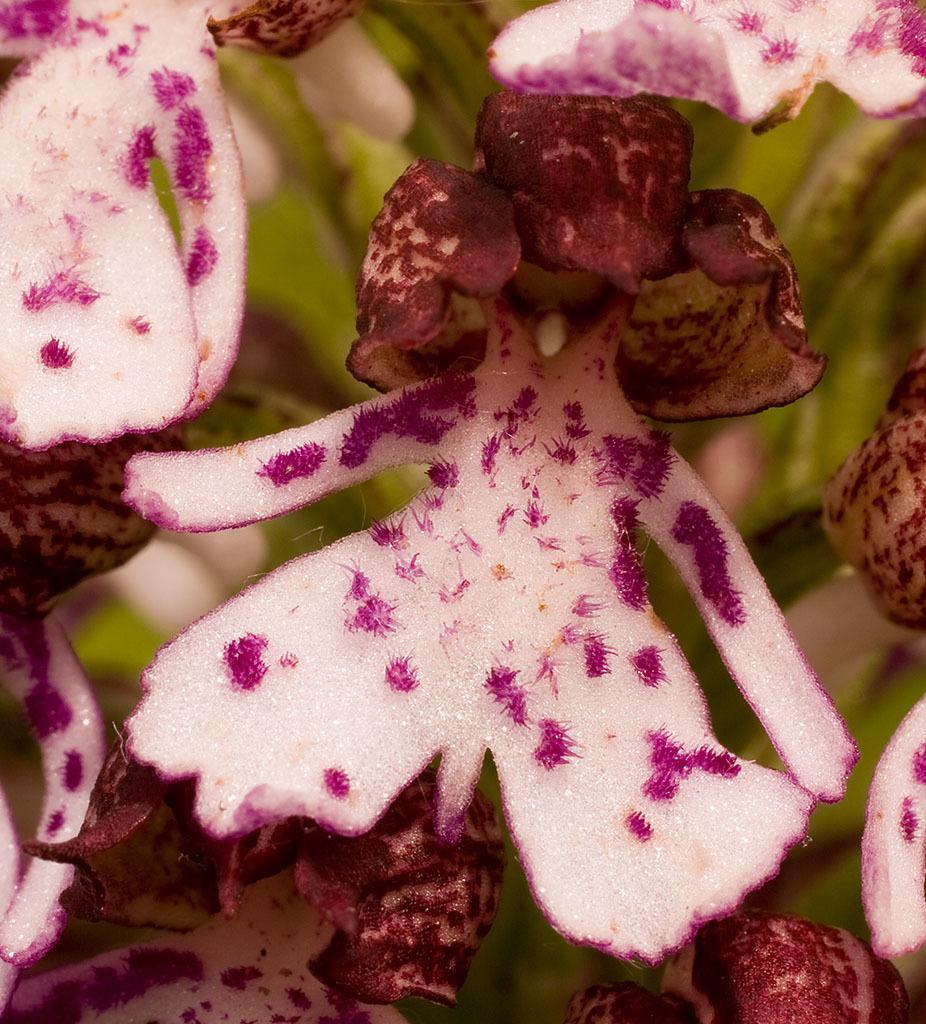In one or two sentences, can you explain what this image depicts? In the center of the image there are many flowers. 